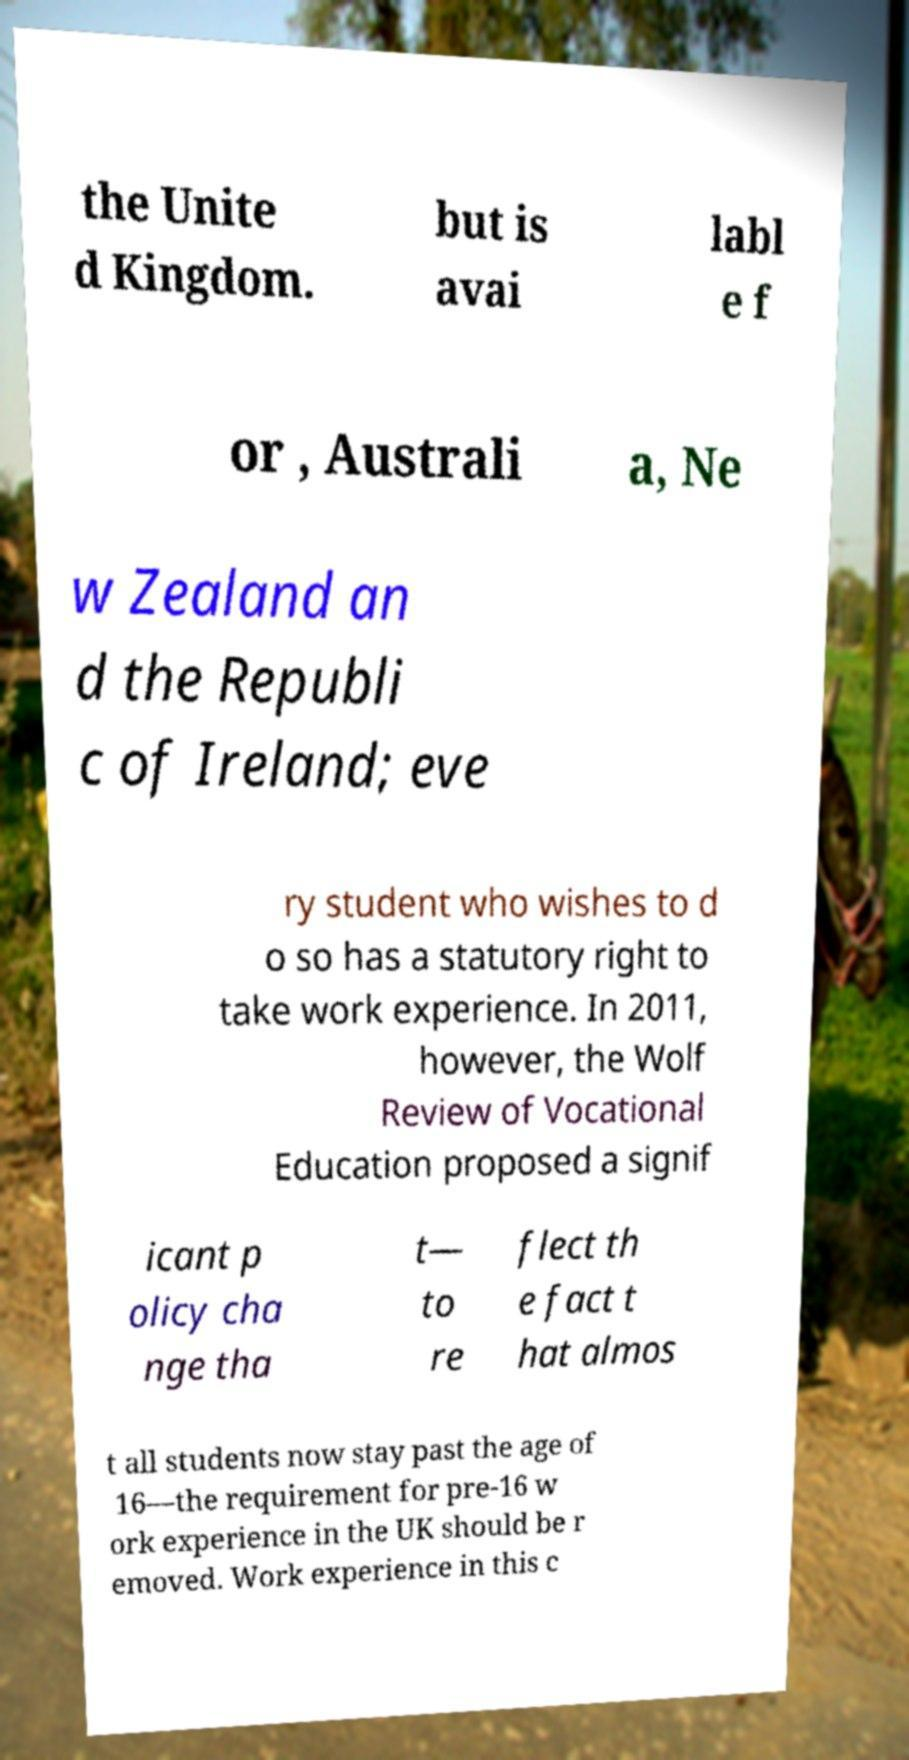What messages or text are displayed in this image? I need them in a readable, typed format. the Unite d Kingdom. but is avai labl e f or , Australi a, Ne w Zealand an d the Republi c of Ireland; eve ry student who wishes to d o so has a statutory right to take work experience. In 2011, however, the Wolf Review of Vocational Education proposed a signif icant p olicy cha nge tha t— to re flect th e fact t hat almos t all students now stay past the age of 16—the requirement for pre-16 w ork experience in the UK should be r emoved. Work experience in this c 